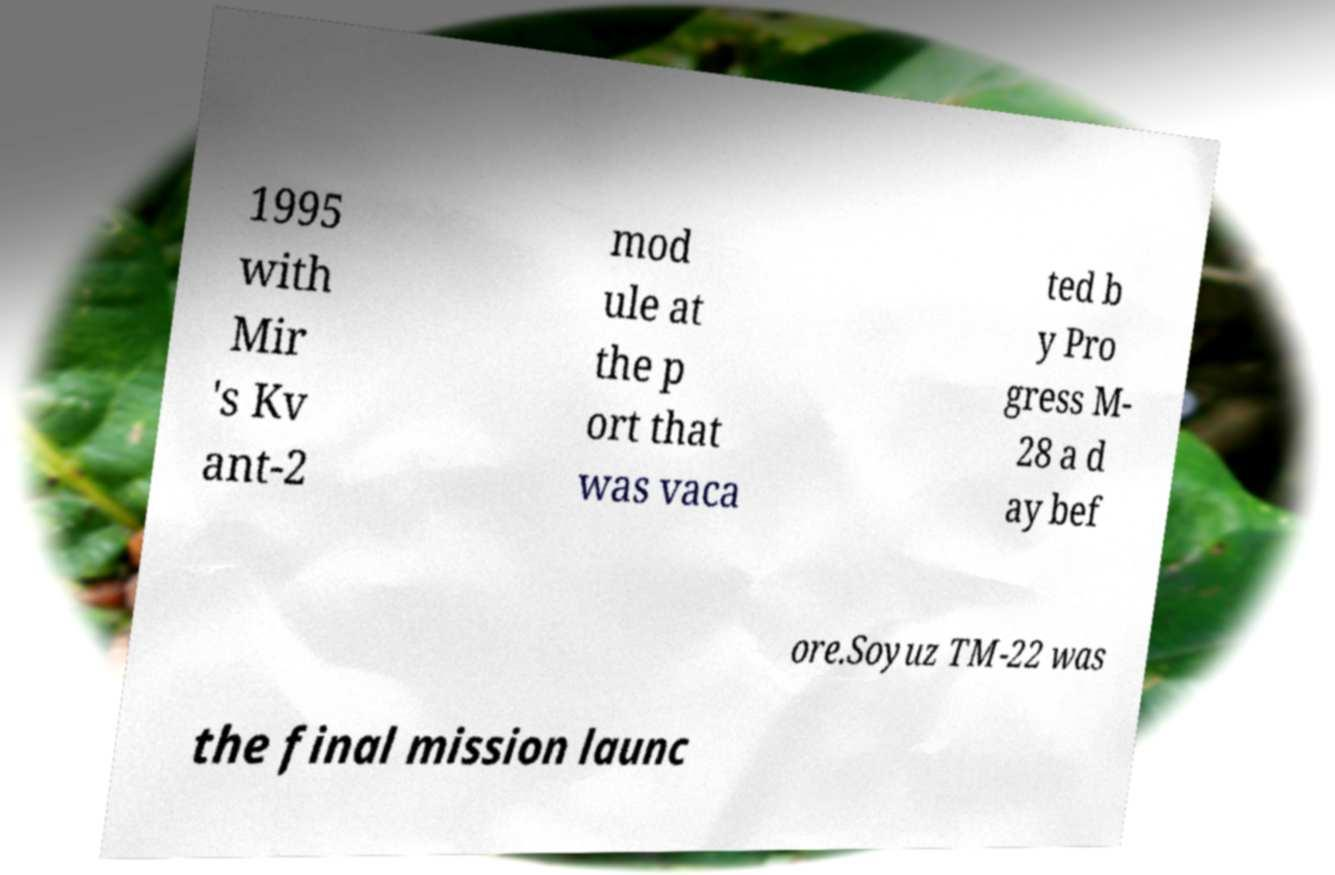Could you assist in decoding the text presented in this image and type it out clearly? 1995 with Mir 's Kv ant-2 mod ule at the p ort that was vaca ted b y Pro gress M- 28 a d ay bef ore.Soyuz TM-22 was the final mission launc 